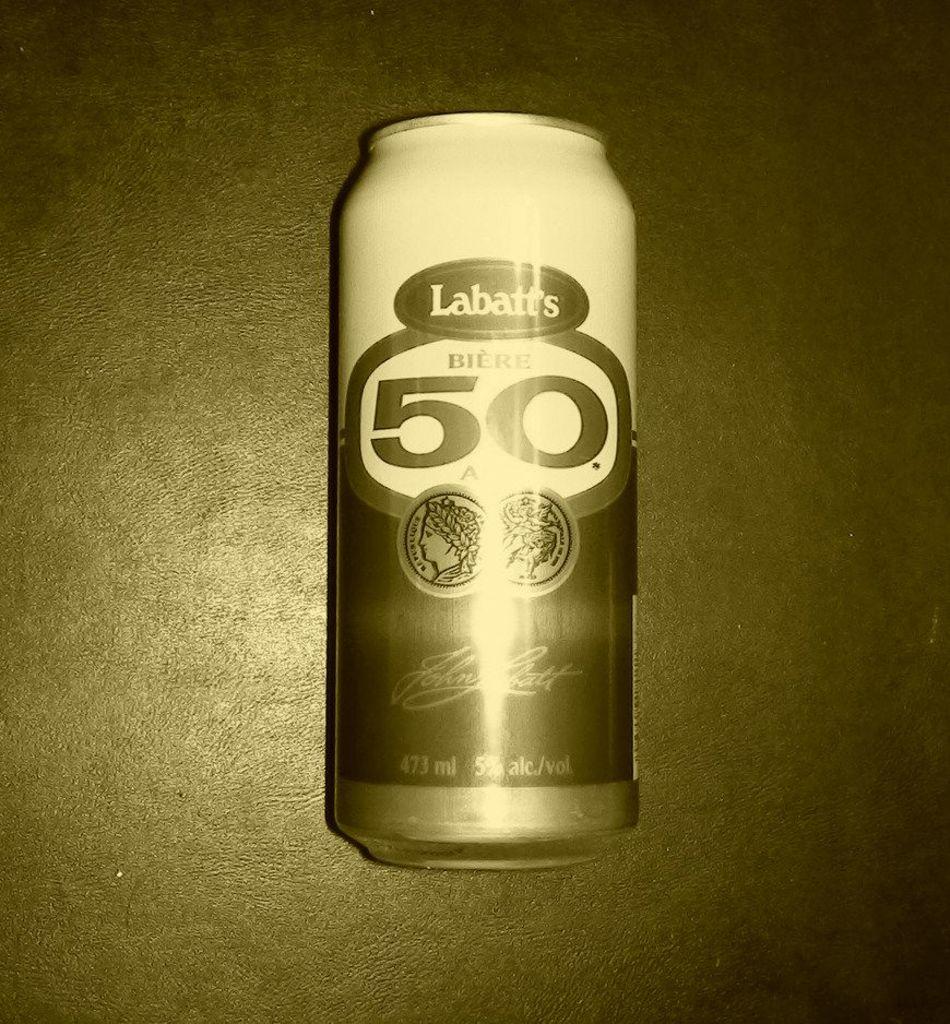What is the brand name of the drink?
Your answer should be very brief. Labatt's. 